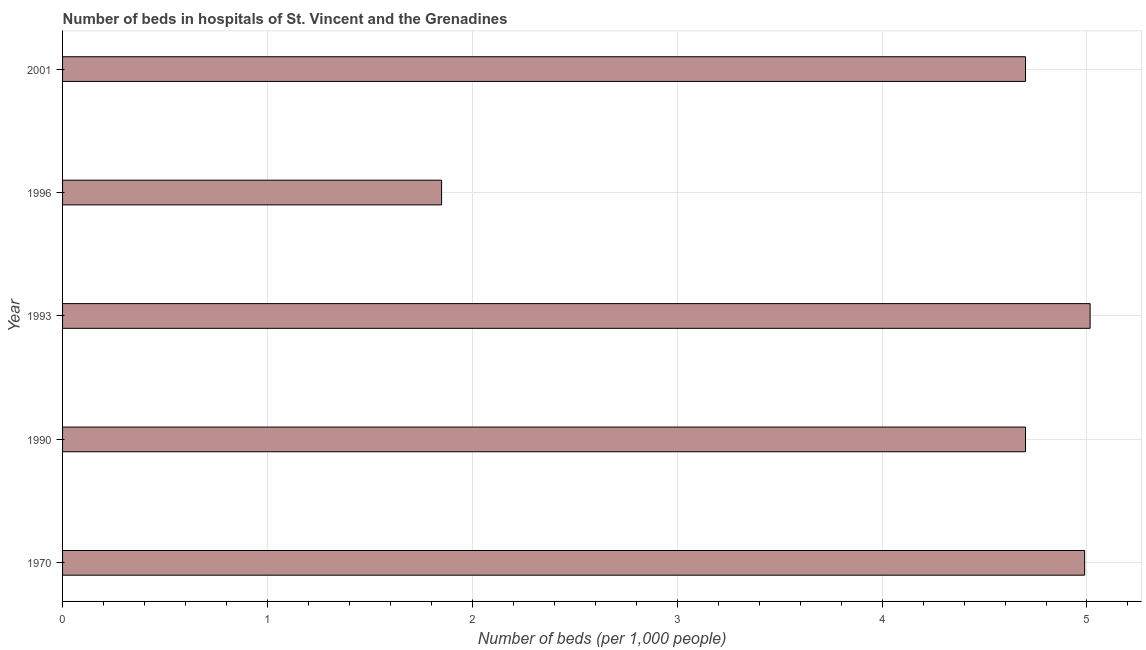Does the graph contain any zero values?
Offer a very short reply. No. Does the graph contain grids?
Provide a succinct answer. Yes. What is the title of the graph?
Your answer should be very brief. Number of beds in hospitals of St. Vincent and the Grenadines. What is the label or title of the X-axis?
Provide a short and direct response. Number of beds (per 1,0 people). What is the label or title of the Y-axis?
Provide a short and direct response. Year. What is the number of hospital beds in 1970?
Your answer should be very brief. 4.99. Across all years, what is the maximum number of hospital beds?
Your answer should be very brief. 5.02. Across all years, what is the minimum number of hospital beds?
Ensure brevity in your answer.  1.85. What is the sum of the number of hospital beds?
Give a very brief answer. 21.25. What is the difference between the number of hospital beds in 1996 and 2001?
Your answer should be very brief. -2.85. What is the average number of hospital beds per year?
Your response must be concise. 4.25. What is the median number of hospital beds?
Your answer should be very brief. 4.7. In how many years, is the number of hospital beds greater than 2.4 %?
Give a very brief answer. 4. Do a majority of the years between 1990 and 1993 (inclusive) have number of hospital beds greater than 3.2 %?
Your answer should be compact. Yes. What is the ratio of the number of hospital beds in 1990 to that in 1993?
Offer a very short reply. 0.94. Is the number of hospital beds in 1993 less than that in 1996?
Offer a terse response. No. What is the difference between the highest and the second highest number of hospital beds?
Your response must be concise. 0.03. What is the difference between the highest and the lowest number of hospital beds?
Offer a terse response. 3.17. In how many years, is the number of hospital beds greater than the average number of hospital beds taken over all years?
Your answer should be very brief. 4. Are all the bars in the graph horizontal?
Your response must be concise. Yes. How many years are there in the graph?
Offer a terse response. 5. What is the difference between two consecutive major ticks on the X-axis?
Offer a very short reply. 1. Are the values on the major ticks of X-axis written in scientific E-notation?
Your answer should be compact. No. What is the Number of beds (per 1,000 people) of 1970?
Provide a succinct answer. 4.99. What is the Number of beds (per 1,000 people) in 1990?
Offer a very short reply. 4.7. What is the Number of beds (per 1,000 people) in 1993?
Make the answer very short. 5.02. What is the Number of beds (per 1,000 people) of 1996?
Your response must be concise. 1.85. What is the Number of beds (per 1,000 people) of 2001?
Give a very brief answer. 4.7. What is the difference between the Number of beds (per 1,000 people) in 1970 and 1990?
Give a very brief answer. 0.29. What is the difference between the Number of beds (per 1,000 people) in 1970 and 1993?
Your answer should be very brief. -0.03. What is the difference between the Number of beds (per 1,000 people) in 1970 and 1996?
Offer a very short reply. 3.14. What is the difference between the Number of beds (per 1,000 people) in 1970 and 2001?
Make the answer very short. 0.29. What is the difference between the Number of beds (per 1,000 people) in 1990 and 1993?
Provide a succinct answer. -0.32. What is the difference between the Number of beds (per 1,000 people) in 1990 and 1996?
Ensure brevity in your answer.  2.85. What is the difference between the Number of beds (per 1,000 people) in 1993 and 1996?
Offer a terse response. 3.17. What is the difference between the Number of beds (per 1,000 people) in 1993 and 2001?
Keep it short and to the point. 0.32. What is the difference between the Number of beds (per 1,000 people) in 1996 and 2001?
Offer a very short reply. -2.85. What is the ratio of the Number of beds (per 1,000 people) in 1970 to that in 1990?
Your answer should be compact. 1.06. What is the ratio of the Number of beds (per 1,000 people) in 1970 to that in 1993?
Your answer should be very brief. 0.99. What is the ratio of the Number of beds (per 1,000 people) in 1970 to that in 1996?
Give a very brief answer. 2.7. What is the ratio of the Number of beds (per 1,000 people) in 1970 to that in 2001?
Make the answer very short. 1.06. What is the ratio of the Number of beds (per 1,000 people) in 1990 to that in 1993?
Your answer should be very brief. 0.94. What is the ratio of the Number of beds (per 1,000 people) in 1990 to that in 1996?
Provide a short and direct response. 2.54. What is the ratio of the Number of beds (per 1,000 people) in 1993 to that in 1996?
Ensure brevity in your answer.  2.71. What is the ratio of the Number of beds (per 1,000 people) in 1993 to that in 2001?
Your response must be concise. 1.07. What is the ratio of the Number of beds (per 1,000 people) in 1996 to that in 2001?
Offer a terse response. 0.39. 